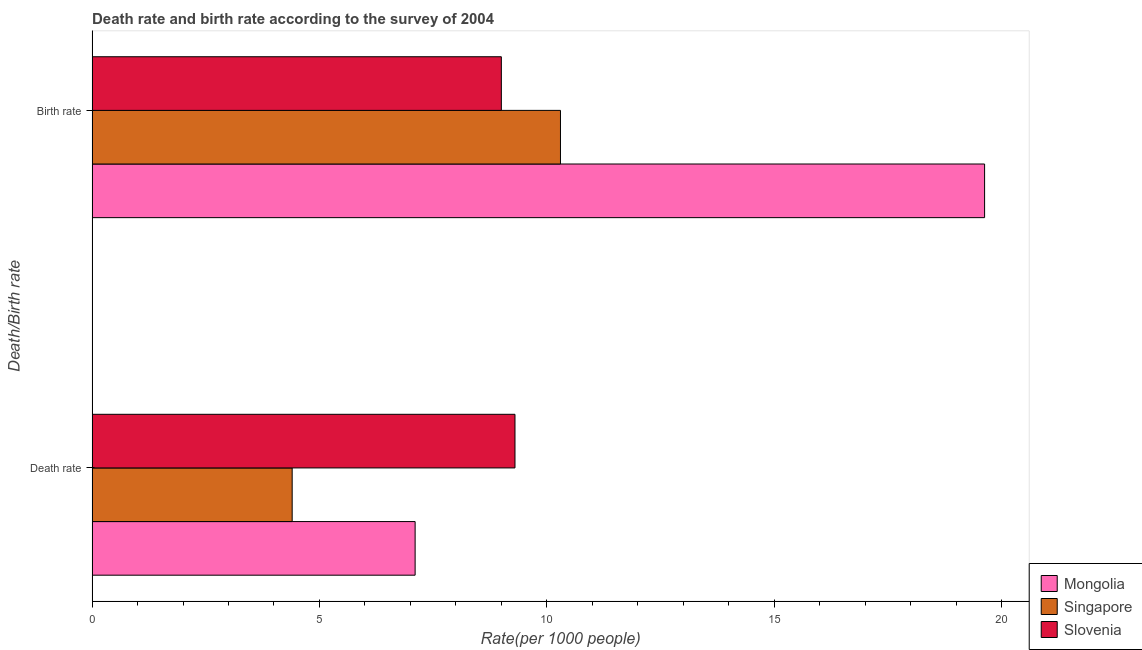Are the number of bars on each tick of the Y-axis equal?
Make the answer very short. Yes. How many bars are there on the 1st tick from the top?
Ensure brevity in your answer.  3. What is the label of the 2nd group of bars from the top?
Your response must be concise. Death rate. Across all countries, what is the maximum birth rate?
Keep it short and to the point. 19.63. Across all countries, what is the minimum birth rate?
Your response must be concise. 9. In which country was the birth rate maximum?
Make the answer very short. Mongolia. In which country was the birth rate minimum?
Make the answer very short. Slovenia. What is the total death rate in the graph?
Provide a short and direct response. 20.8. What is the difference between the death rate in Slovenia and that in Mongolia?
Your answer should be compact. 2.2. What is the difference between the birth rate in Mongolia and the death rate in Singapore?
Give a very brief answer. 15.23. What is the average death rate per country?
Your answer should be very brief. 6.93. What is the difference between the death rate and birth rate in Mongolia?
Provide a short and direct response. -12.52. In how many countries, is the birth rate greater than 13 ?
Give a very brief answer. 1. What is the ratio of the death rate in Mongolia to that in Singapore?
Ensure brevity in your answer.  1.61. What does the 1st bar from the top in Death rate represents?
Offer a very short reply. Slovenia. What does the 3rd bar from the bottom in Death rate represents?
Make the answer very short. Slovenia. How many bars are there?
Your answer should be very brief. 6. Are all the bars in the graph horizontal?
Provide a short and direct response. Yes. Are the values on the major ticks of X-axis written in scientific E-notation?
Offer a terse response. No. Does the graph contain grids?
Provide a short and direct response. No. Where does the legend appear in the graph?
Give a very brief answer. Bottom right. How are the legend labels stacked?
Keep it short and to the point. Vertical. What is the title of the graph?
Offer a terse response. Death rate and birth rate according to the survey of 2004. Does "Costa Rica" appear as one of the legend labels in the graph?
Provide a short and direct response. No. What is the label or title of the X-axis?
Keep it short and to the point. Rate(per 1000 people). What is the label or title of the Y-axis?
Keep it short and to the point. Death/Birth rate. What is the Rate(per 1000 people) in Mongolia in Death rate?
Provide a succinct answer. 7.1. What is the Rate(per 1000 people) of Singapore in Death rate?
Provide a succinct answer. 4.4. What is the Rate(per 1000 people) of Mongolia in Birth rate?
Provide a succinct answer. 19.63. What is the Rate(per 1000 people) of Singapore in Birth rate?
Provide a short and direct response. 10.3. What is the Rate(per 1000 people) of Slovenia in Birth rate?
Give a very brief answer. 9. Across all Death/Birth rate, what is the maximum Rate(per 1000 people) of Mongolia?
Provide a short and direct response. 19.63. Across all Death/Birth rate, what is the maximum Rate(per 1000 people) of Singapore?
Your response must be concise. 10.3. Across all Death/Birth rate, what is the minimum Rate(per 1000 people) in Mongolia?
Your answer should be compact. 7.1. Across all Death/Birth rate, what is the minimum Rate(per 1000 people) of Slovenia?
Make the answer very short. 9. What is the total Rate(per 1000 people) of Mongolia in the graph?
Ensure brevity in your answer.  26.73. What is the difference between the Rate(per 1000 people) in Mongolia in Death rate and that in Birth rate?
Your answer should be compact. -12.52. What is the difference between the Rate(per 1000 people) of Slovenia in Death rate and that in Birth rate?
Offer a very short reply. 0.3. What is the difference between the Rate(per 1000 people) in Mongolia in Death rate and the Rate(per 1000 people) in Singapore in Birth rate?
Your answer should be compact. -3.2. What is the difference between the Rate(per 1000 people) of Mongolia in Death rate and the Rate(per 1000 people) of Slovenia in Birth rate?
Give a very brief answer. -1.9. What is the difference between the Rate(per 1000 people) in Singapore in Death rate and the Rate(per 1000 people) in Slovenia in Birth rate?
Make the answer very short. -4.6. What is the average Rate(per 1000 people) in Mongolia per Death/Birth rate?
Give a very brief answer. 13.37. What is the average Rate(per 1000 people) in Singapore per Death/Birth rate?
Provide a short and direct response. 7.35. What is the average Rate(per 1000 people) in Slovenia per Death/Birth rate?
Ensure brevity in your answer.  9.15. What is the difference between the Rate(per 1000 people) of Mongolia and Rate(per 1000 people) of Singapore in Death rate?
Your response must be concise. 2.7. What is the difference between the Rate(per 1000 people) of Mongolia and Rate(per 1000 people) of Slovenia in Death rate?
Provide a short and direct response. -2.2. What is the difference between the Rate(per 1000 people) in Singapore and Rate(per 1000 people) in Slovenia in Death rate?
Make the answer very short. -4.9. What is the difference between the Rate(per 1000 people) in Mongolia and Rate(per 1000 people) in Singapore in Birth rate?
Your response must be concise. 9.33. What is the difference between the Rate(per 1000 people) in Mongolia and Rate(per 1000 people) in Slovenia in Birth rate?
Your answer should be very brief. 10.63. What is the ratio of the Rate(per 1000 people) in Mongolia in Death rate to that in Birth rate?
Ensure brevity in your answer.  0.36. What is the ratio of the Rate(per 1000 people) of Singapore in Death rate to that in Birth rate?
Ensure brevity in your answer.  0.43. What is the difference between the highest and the second highest Rate(per 1000 people) in Mongolia?
Ensure brevity in your answer.  12.52. What is the difference between the highest and the second highest Rate(per 1000 people) in Slovenia?
Provide a short and direct response. 0.3. What is the difference between the highest and the lowest Rate(per 1000 people) in Mongolia?
Make the answer very short. 12.52. 